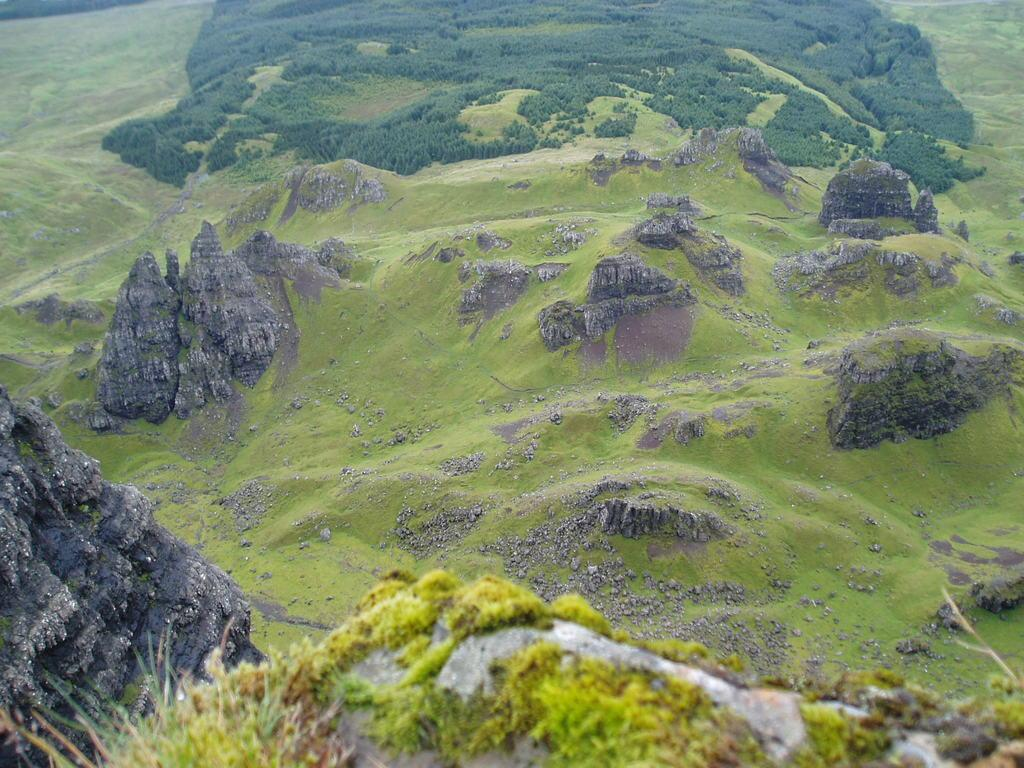What perspective is the image taken from? The image is taken from a top view. What type of geographical features can be seen in the image? There are rocky mountains and hills in the image. What is growing on the hills in the image? Trees and grass are visible on the hills in the image. What type of club is being used to hit the ball in the image? There is no club or ball present in the image; it features a top view of rocky mountains, hills, trees, and grass. What society is responsible for maintaining the landscape in the image? The image does not provide information about any specific society responsible for maintaining the landscape. 